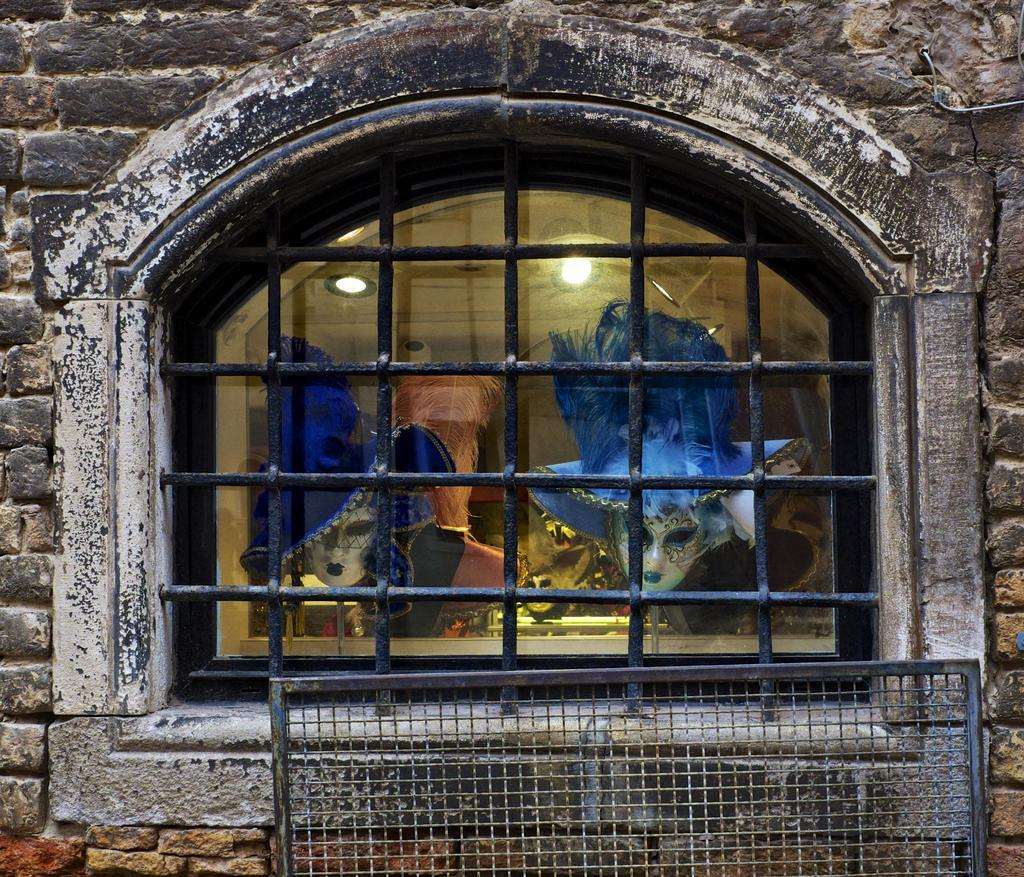What is a prominent feature of the wall in the image? There is a window in the wall. What can be seen through the window in the image? Masks and lights are visible through the window glass. What type of material is present in the image? There is a mesh in the image. Can you describe the wall's appearance? The wall has a window and a mesh. What type of creature can be seen bursting through the mesh in the image? There is no creature present in the image, nor is there any indication of a creature bursting through the mesh. 